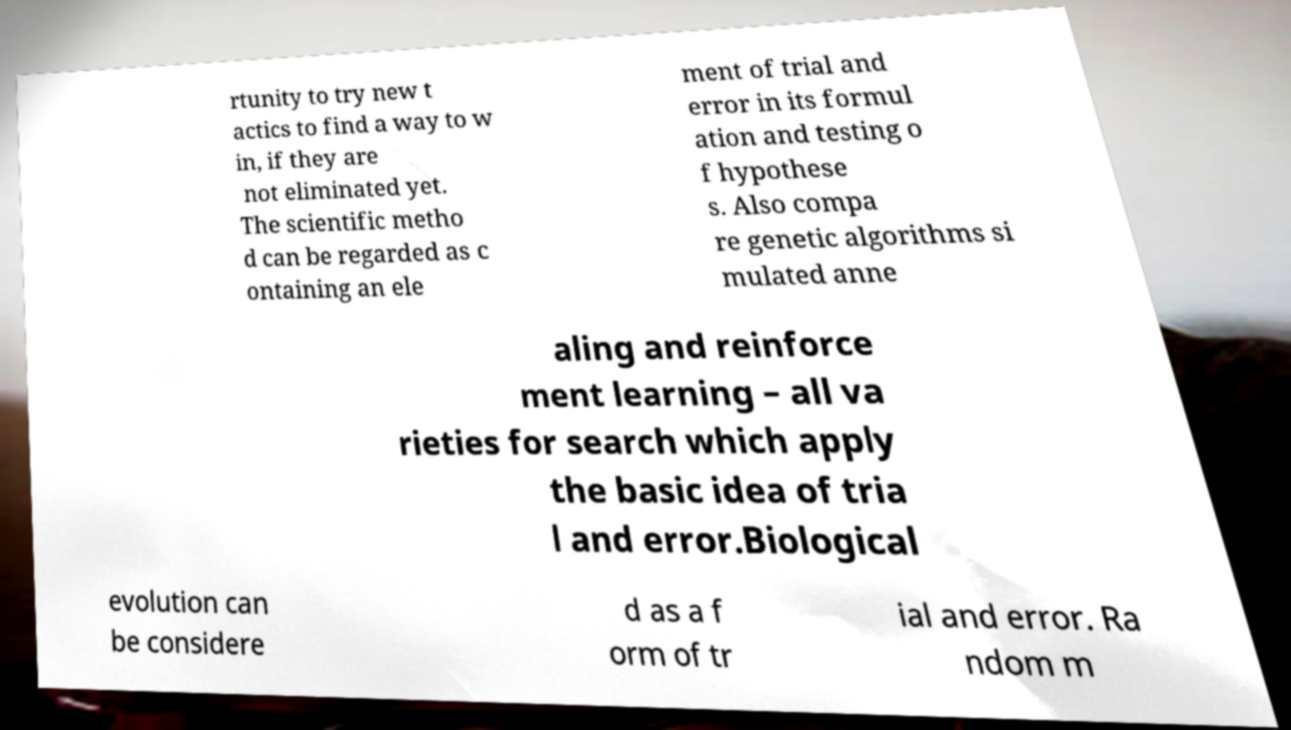Can you read and provide the text displayed in the image?This photo seems to have some interesting text. Can you extract and type it out for me? rtunity to try new t actics to find a way to w in, if they are not eliminated yet. The scientific metho d can be regarded as c ontaining an ele ment of trial and error in its formul ation and testing o f hypothese s. Also compa re genetic algorithms si mulated anne aling and reinforce ment learning – all va rieties for search which apply the basic idea of tria l and error.Biological evolution can be considere d as a f orm of tr ial and error. Ra ndom m 